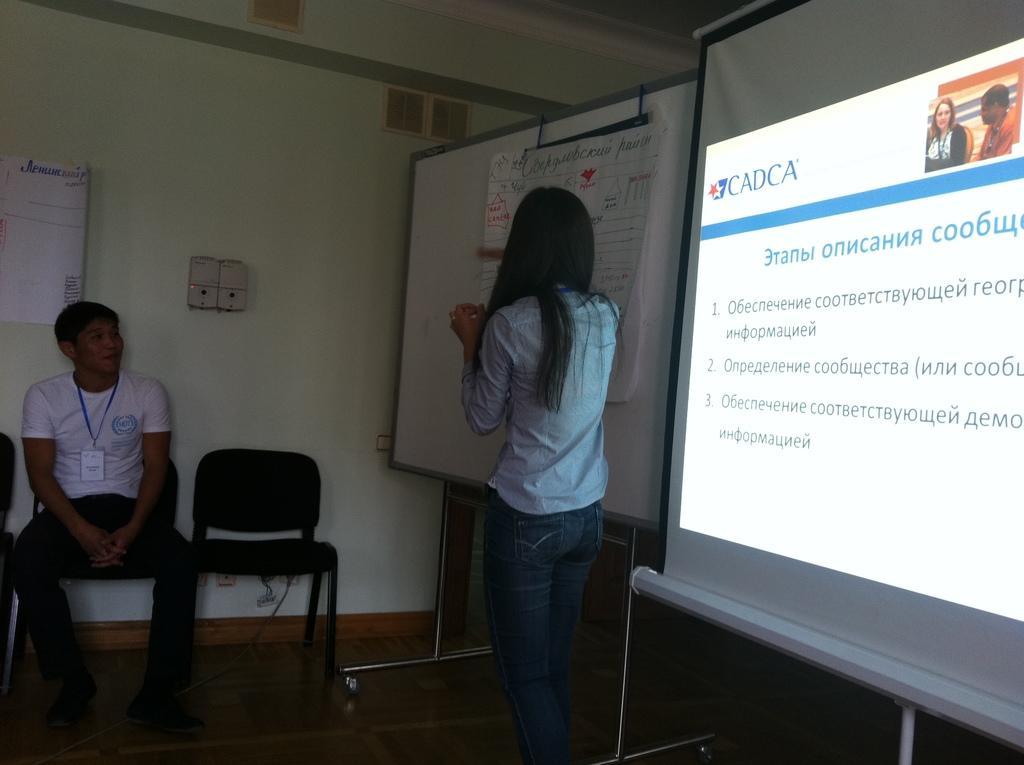How would you summarize this image in a sentence or two? In this image In the middle there is a woman she wear trouser and shirt. On the left there is a man he is sitting on the chair. In the background there is a screen, white board and wall. 